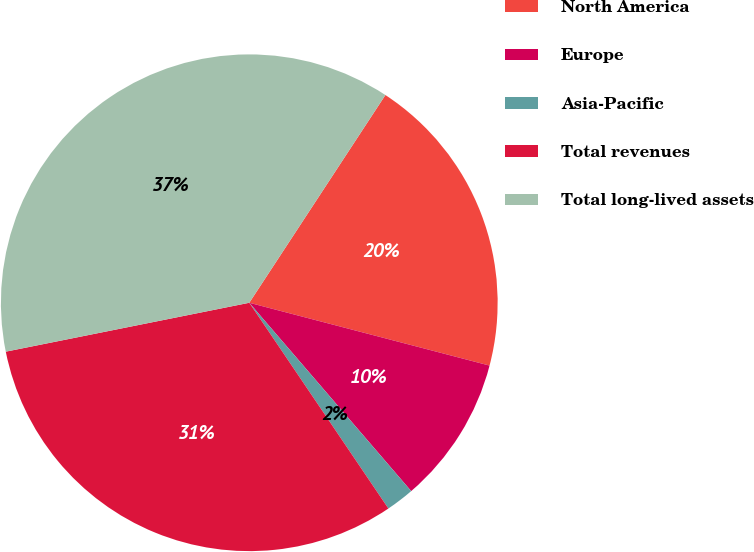<chart> <loc_0><loc_0><loc_500><loc_500><pie_chart><fcel>North America<fcel>Europe<fcel>Asia-Pacific<fcel>Total revenues<fcel>Total long-lived assets<nl><fcel>19.84%<fcel>9.63%<fcel>1.84%<fcel>31.31%<fcel>37.39%<nl></chart> 